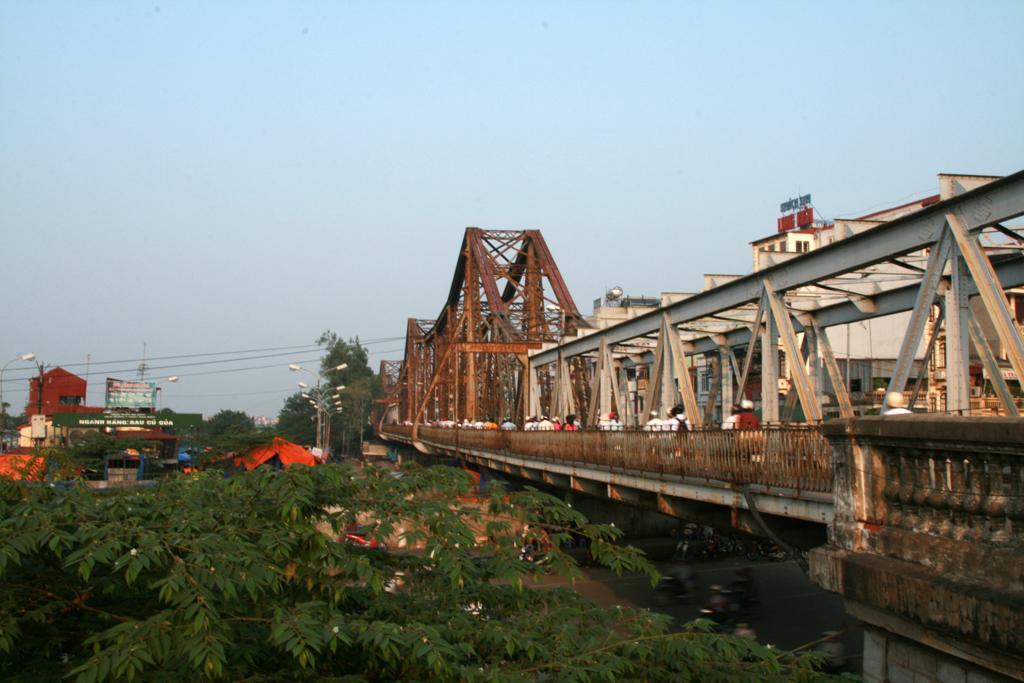Can you describe this image briefly? In the foreground of this image, there is a tree at the bottom and few vehicles moving on the road. On the right, there is a bridge. In the background, there are buildings, boards, poles, cables and the sky. 